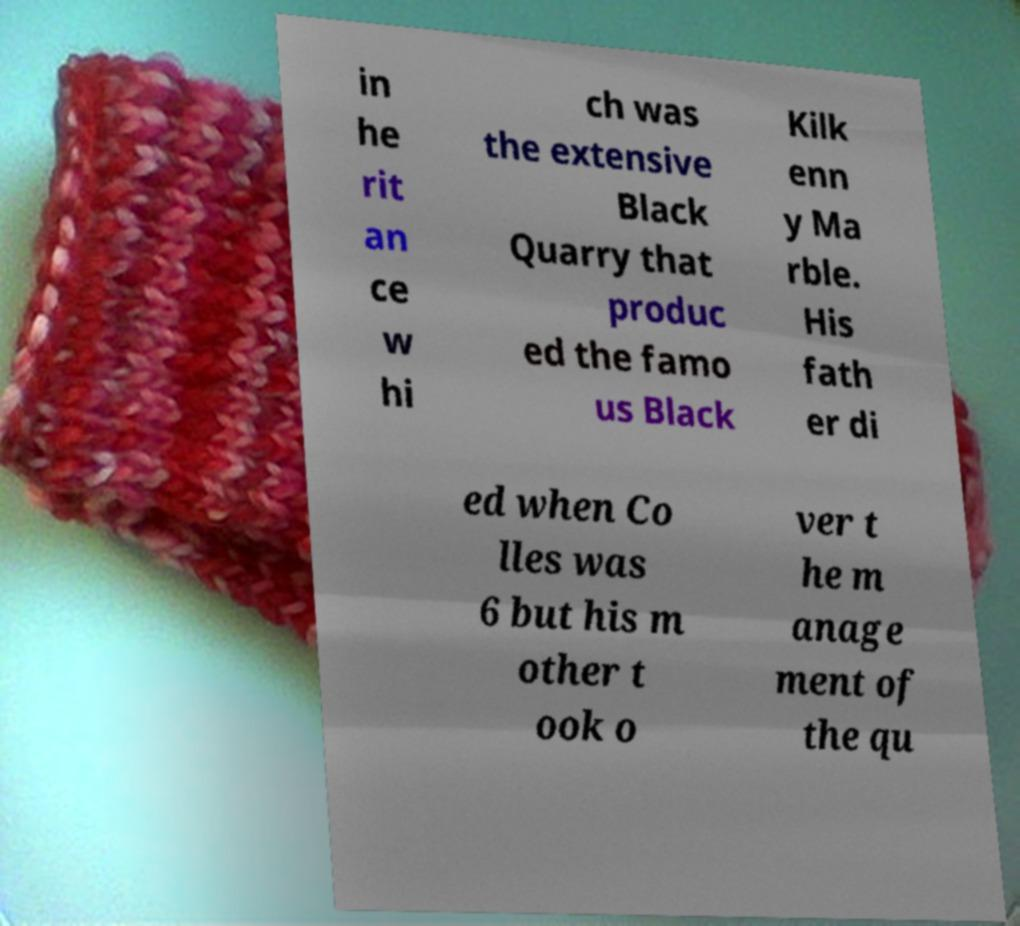Please identify and transcribe the text found in this image. in he rit an ce w hi ch was the extensive Black Quarry that produc ed the famo us Black Kilk enn y Ma rble. His fath er di ed when Co lles was 6 but his m other t ook o ver t he m anage ment of the qu 